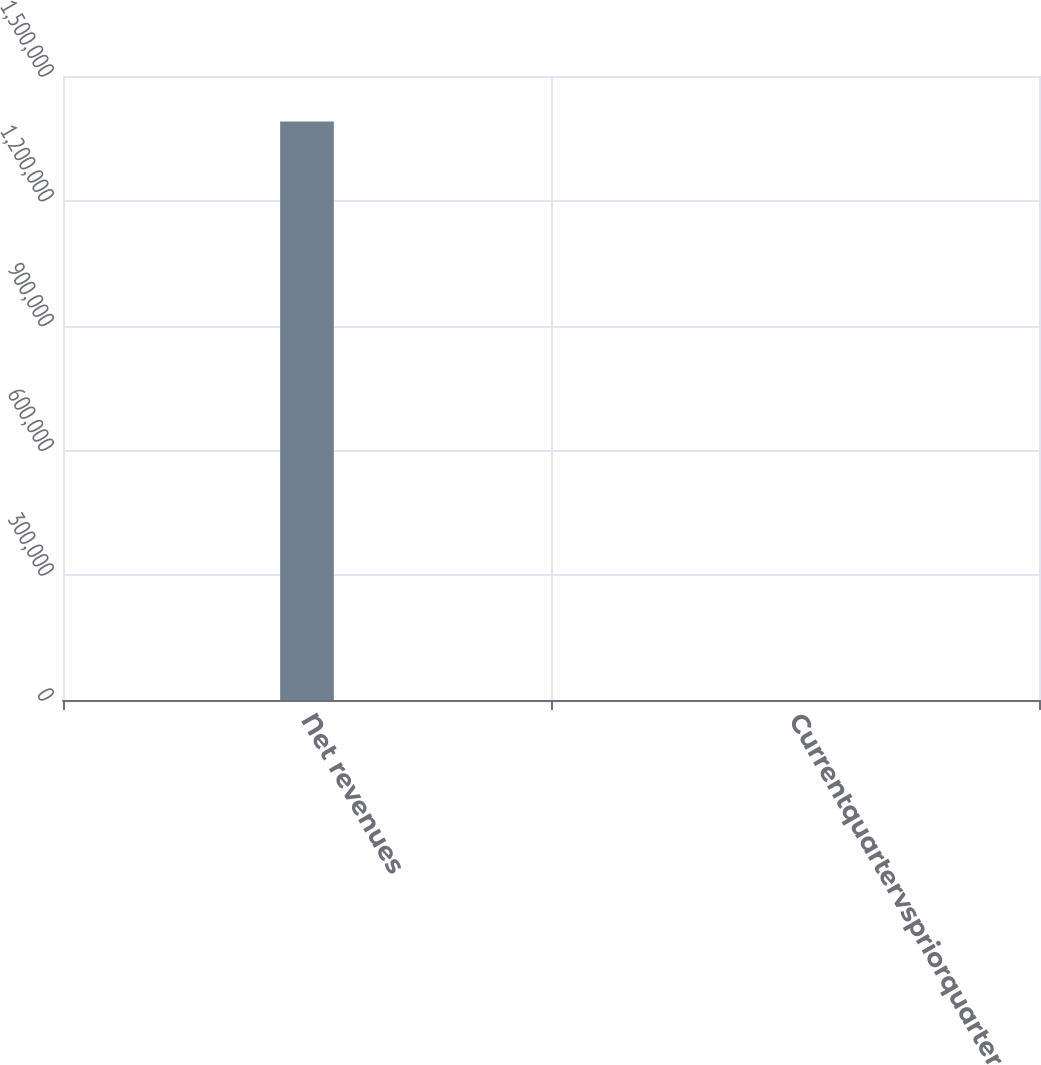<chart> <loc_0><loc_0><loc_500><loc_500><bar_chart><fcel>Net revenues<fcel>Currentquartervspriorquarter<nl><fcel>1.39042e+06<fcel>5<nl></chart> 